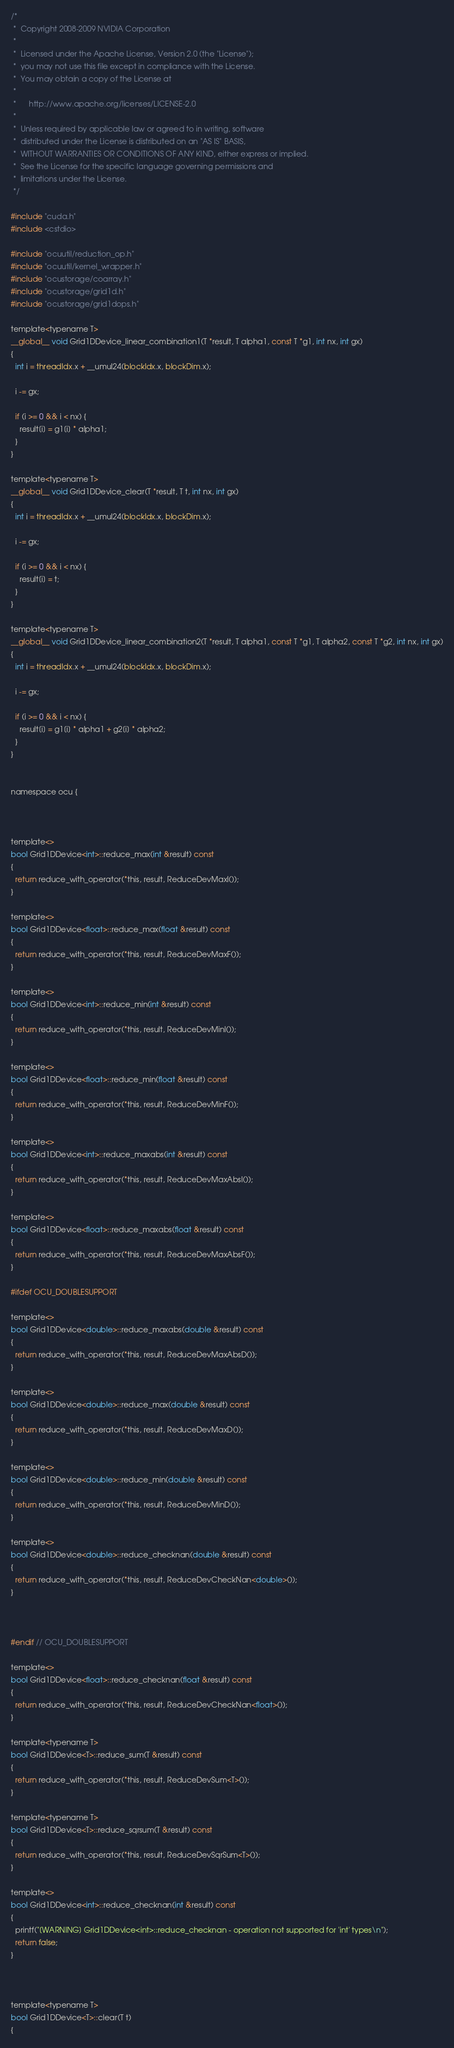Convert code to text. <code><loc_0><loc_0><loc_500><loc_500><_Cuda_>/*
 *  Copyright 2008-2009 NVIDIA Corporation
 *
 *  Licensed under the Apache License, Version 2.0 (the "License");
 *  you may not use this file except in compliance with the License.
 *  You may obtain a copy of the License at
 *
 *      http://www.apache.org/licenses/LICENSE-2.0
 *
 *  Unless required by applicable law or agreed to in writing, software
 *  distributed under the License is distributed on an "AS IS" BASIS,
 *  WITHOUT WARRANTIES OR CONDITIONS OF ANY KIND, either express or implied.
 *  See the License for the specific language governing permissions and
 *  limitations under the License.
 */

#include "cuda.h"
#include <cstdio>

#include "ocuutil/reduction_op.h"
#include "ocuutil/kernel_wrapper.h"
#include "ocustorage/coarray.h"
#include "ocustorage/grid1d.h"
#include "ocustorage/grid1dops.h"

template<typename T>
__global__ void Grid1DDevice_linear_combination1(T *result, T alpha1, const T *g1, int nx, int gx)
{
  int i = threadIdx.x + __umul24(blockIdx.x, blockDim.x);
  
  i -= gx;

  if (i >= 0 && i < nx) {
    result[i] = g1[i] * alpha1;  
  }
}

template<typename T>
__global__ void Grid1DDevice_clear(T *result, T t, int nx, int gx)
{
  int i = threadIdx.x + __umul24(blockIdx.x, blockDim.x);
  
  i -= gx;

  if (i >= 0 && i < nx) {
    result[i] = t;
  }
}

template<typename T>
__global__ void Grid1DDevice_linear_combination2(T *result, T alpha1, const T *g1, T alpha2, const T *g2, int nx, int gx)
{
  int i = threadIdx.x + __umul24(blockIdx.x, blockDim.x);
  
  i -= gx;

  if (i >= 0 && i < nx) {
    result[i] = g1[i] * alpha1 + g2[i] * alpha2;  
  }
}


namespace ocu {


  
template<>
bool Grid1DDevice<int>::reduce_max(int &result) const
{
  return reduce_with_operator(*this, result, ReduceDevMaxI());
}

template<>
bool Grid1DDevice<float>::reduce_max(float &result) const
{
  return reduce_with_operator(*this, result, ReduceDevMaxF());
}
  
template<>
bool Grid1DDevice<int>::reduce_min(int &result) const
{
  return reduce_with_operator(*this, result, ReduceDevMinI());
}

template<>
bool Grid1DDevice<float>::reduce_min(float &result) const
{
  return reduce_with_operator(*this, result, ReduceDevMinF());
}
  
template<>
bool Grid1DDevice<int>::reduce_maxabs(int &result) const
{
  return reduce_with_operator(*this, result, ReduceDevMaxAbsI());
}

template<>
bool Grid1DDevice<float>::reduce_maxabs(float &result) const
{
  return reduce_with_operator(*this, result, ReduceDevMaxAbsF());
}

#ifdef OCU_DOUBLESUPPORT

template<>
bool Grid1DDevice<double>::reduce_maxabs(double &result) const
{
  return reduce_with_operator(*this, result, ReduceDevMaxAbsD());
}

template<>
bool Grid1DDevice<double>::reduce_max(double &result) const
{
  return reduce_with_operator(*this, result, ReduceDevMaxD());
}

template<>
bool Grid1DDevice<double>::reduce_min(double &result) const
{
  return reduce_with_operator(*this, result, ReduceDevMinD());
}

template<>
bool Grid1DDevice<double>::reduce_checknan(double &result) const
{
  return reduce_with_operator(*this, result, ReduceDevCheckNan<double>());
}



#endif // OCU_DOUBLESUPPORT

template<>
bool Grid1DDevice<float>::reduce_checknan(float &result) const
{
  return reduce_with_operator(*this, result, ReduceDevCheckNan<float>());
}

template<typename T>
bool Grid1DDevice<T>::reduce_sum(T &result) const
{
  return reduce_with_operator(*this, result, ReduceDevSum<T>());
}

template<typename T>
bool Grid1DDevice<T>::reduce_sqrsum(T &result) const
{
  return reduce_with_operator(*this, result, ReduceDevSqrSum<T>());
}

template<>
bool Grid1DDevice<int>::reduce_checknan(int &result) const
{
  printf("[WARNING] Grid1DDevice<int>::reduce_checknan - operation not supported for 'int' types\n");
  return false;
}



template<typename T>
bool Grid1DDevice<T>::clear(T t)
{</code> 